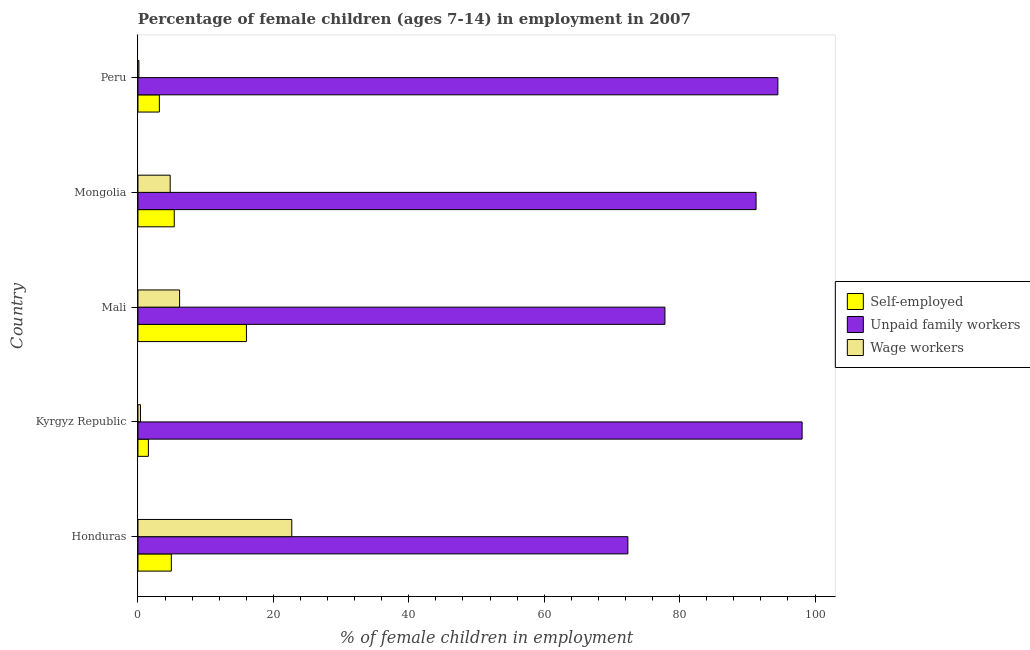How many different coloured bars are there?
Your answer should be compact. 3. How many groups of bars are there?
Your answer should be compact. 5. Are the number of bars on each tick of the Y-axis equal?
Your answer should be very brief. Yes. What is the label of the 3rd group of bars from the top?
Offer a terse response. Mali. In how many cases, is the number of bars for a given country not equal to the number of legend labels?
Make the answer very short. 0. What is the percentage of children employed as unpaid family workers in Peru?
Provide a short and direct response. 94.51. Across all countries, what is the maximum percentage of self employed children?
Your answer should be very brief. 16.02. Across all countries, what is the minimum percentage of self employed children?
Offer a very short reply. 1.54. In which country was the percentage of children employed as unpaid family workers maximum?
Provide a succinct answer. Kyrgyz Republic. In which country was the percentage of children employed as unpaid family workers minimum?
Give a very brief answer. Honduras. What is the total percentage of children employed as unpaid family workers in the graph?
Your answer should be very brief. 434.08. What is the difference between the percentage of self employed children in Kyrgyz Republic and that in Mongolia?
Your response must be concise. -3.82. What is the difference between the percentage of children employed as wage workers in Mongolia and the percentage of self employed children in Peru?
Your response must be concise. 1.6. What is the average percentage of children employed as wage workers per country?
Offer a terse response. 6.83. What is the difference between the percentage of children employed as wage workers and percentage of children employed as unpaid family workers in Mali?
Offer a very short reply. -71.68. What is the ratio of the percentage of self employed children in Kyrgyz Republic to that in Mali?
Your answer should be compact. 0.1. Is the percentage of children employed as unpaid family workers in Mongolia less than that in Peru?
Make the answer very short. Yes. What is the difference between the highest and the second highest percentage of children employed as unpaid family workers?
Your response must be concise. 3.58. What is the difference between the highest and the lowest percentage of self employed children?
Offer a terse response. 14.48. What does the 2nd bar from the top in Mali represents?
Ensure brevity in your answer.  Unpaid family workers. What does the 3rd bar from the bottom in Peru represents?
Provide a short and direct response. Wage workers. How many bars are there?
Your answer should be compact. 15. Are the values on the major ticks of X-axis written in scientific E-notation?
Offer a terse response. No. Does the graph contain grids?
Your answer should be compact. No. Where does the legend appear in the graph?
Give a very brief answer. Center right. What is the title of the graph?
Give a very brief answer. Percentage of female children (ages 7-14) in employment in 2007. What is the label or title of the X-axis?
Offer a terse response. % of female children in employment. What is the % of female children in employment of Self-employed in Honduras?
Offer a terse response. 4.93. What is the % of female children in employment of Unpaid family workers in Honduras?
Offer a very short reply. 72.36. What is the % of female children in employment of Wage workers in Honduras?
Provide a short and direct response. 22.72. What is the % of female children in employment in Self-employed in Kyrgyz Republic?
Your response must be concise. 1.54. What is the % of female children in employment in Unpaid family workers in Kyrgyz Republic?
Your response must be concise. 98.09. What is the % of female children in employment of Wage workers in Kyrgyz Republic?
Keep it short and to the point. 0.37. What is the % of female children in employment of Self-employed in Mali?
Ensure brevity in your answer.  16.02. What is the % of female children in employment of Unpaid family workers in Mali?
Ensure brevity in your answer.  77.83. What is the % of female children in employment in Wage workers in Mali?
Provide a succinct answer. 6.15. What is the % of female children in employment of Self-employed in Mongolia?
Ensure brevity in your answer.  5.36. What is the % of female children in employment in Unpaid family workers in Mongolia?
Give a very brief answer. 91.29. What is the % of female children in employment of Wage workers in Mongolia?
Keep it short and to the point. 4.76. What is the % of female children in employment in Self-employed in Peru?
Make the answer very short. 3.16. What is the % of female children in employment of Unpaid family workers in Peru?
Provide a short and direct response. 94.51. What is the % of female children in employment of Wage workers in Peru?
Ensure brevity in your answer.  0.14. Across all countries, what is the maximum % of female children in employment of Self-employed?
Offer a very short reply. 16.02. Across all countries, what is the maximum % of female children in employment in Unpaid family workers?
Your response must be concise. 98.09. Across all countries, what is the maximum % of female children in employment of Wage workers?
Your answer should be compact. 22.72. Across all countries, what is the minimum % of female children in employment in Self-employed?
Give a very brief answer. 1.54. Across all countries, what is the minimum % of female children in employment in Unpaid family workers?
Your answer should be compact. 72.36. Across all countries, what is the minimum % of female children in employment in Wage workers?
Provide a succinct answer. 0.14. What is the total % of female children in employment in Self-employed in the graph?
Your answer should be very brief. 31.01. What is the total % of female children in employment in Unpaid family workers in the graph?
Offer a very short reply. 434.08. What is the total % of female children in employment in Wage workers in the graph?
Ensure brevity in your answer.  34.14. What is the difference between the % of female children in employment in Self-employed in Honduras and that in Kyrgyz Republic?
Keep it short and to the point. 3.39. What is the difference between the % of female children in employment in Unpaid family workers in Honduras and that in Kyrgyz Republic?
Keep it short and to the point. -25.73. What is the difference between the % of female children in employment of Wage workers in Honduras and that in Kyrgyz Republic?
Your response must be concise. 22.35. What is the difference between the % of female children in employment of Self-employed in Honduras and that in Mali?
Offer a terse response. -11.09. What is the difference between the % of female children in employment of Unpaid family workers in Honduras and that in Mali?
Make the answer very short. -5.47. What is the difference between the % of female children in employment of Wage workers in Honduras and that in Mali?
Ensure brevity in your answer.  16.57. What is the difference between the % of female children in employment of Self-employed in Honduras and that in Mongolia?
Offer a very short reply. -0.43. What is the difference between the % of female children in employment in Unpaid family workers in Honduras and that in Mongolia?
Your response must be concise. -18.93. What is the difference between the % of female children in employment in Wage workers in Honduras and that in Mongolia?
Provide a short and direct response. 17.96. What is the difference between the % of female children in employment of Self-employed in Honduras and that in Peru?
Make the answer very short. 1.77. What is the difference between the % of female children in employment of Unpaid family workers in Honduras and that in Peru?
Provide a succinct answer. -22.15. What is the difference between the % of female children in employment in Wage workers in Honduras and that in Peru?
Give a very brief answer. 22.58. What is the difference between the % of female children in employment in Self-employed in Kyrgyz Republic and that in Mali?
Keep it short and to the point. -14.48. What is the difference between the % of female children in employment in Unpaid family workers in Kyrgyz Republic and that in Mali?
Provide a succinct answer. 20.26. What is the difference between the % of female children in employment in Wage workers in Kyrgyz Republic and that in Mali?
Your answer should be compact. -5.78. What is the difference between the % of female children in employment in Self-employed in Kyrgyz Republic and that in Mongolia?
Offer a terse response. -3.82. What is the difference between the % of female children in employment of Unpaid family workers in Kyrgyz Republic and that in Mongolia?
Offer a terse response. 6.8. What is the difference between the % of female children in employment of Wage workers in Kyrgyz Republic and that in Mongolia?
Your response must be concise. -4.39. What is the difference between the % of female children in employment of Self-employed in Kyrgyz Republic and that in Peru?
Make the answer very short. -1.62. What is the difference between the % of female children in employment in Unpaid family workers in Kyrgyz Republic and that in Peru?
Give a very brief answer. 3.58. What is the difference between the % of female children in employment in Wage workers in Kyrgyz Republic and that in Peru?
Provide a short and direct response. 0.23. What is the difference between the % of female children in employment of Self-employed in Mali and that in Mongolia?
Offer a terse response. 10.66. What is the difference between the % of female children in employment in Unpaid family workers in Mali and that in Mongolia?
Make the answer very short. -13.46. What is the difference between the % of female children in employment in Wage workers in Mali and that in Mongolia?
Provide a succinct answer. 1.39. What is the difference between the % of female children in employment of Self-employed in Mali and that in Peru?
Your response must be concise. 12.86. What is the difference between the % of female children in employment of Unpaid family workers in Mali and that in Peru?
Your answer should be very brief. -16.68. What is the difference between the % of female children in employment in Wage workers in Mali and that in Peru?
Your answer should be very brief. 6.01. What is the difference between the % of female children in employment of Self-employed in Mongolia and that in Peru?
Offer a very short reply. 2.2. What is the difference between the % of female children in employment in Unpaid family workers in Mongolia and that in Peru?
Your answer should be compact. -3.22. What is the difference between the % of female children in employment in Wage workers in Mongolia and that in Peru?
Your answer should be very brief. 4.62. What is the difference between the % of female children in employment of Self-employed in Honduras and the % of female children in employment of Unpaid family workers in Kyrgyz Republic?
Provide a succinct answer. -93.16. What is the difference between the % of female children in employment of Self-employed in Honduras and the % of female children in employment of Wage workers in Kyrgyz Republic?
Your answer should be compact. 4.56. What is the difference between the % of female children in employment of Unpaid family workers in Honduras and the % of female children in employment of Wage workers in Kyrgyz Republic?
Ensure brevity in your answer.  71.99. What is the difference between the % of female children in employment of Self-employed in Honduras and the % of female children in employment of Unpaid family workers in Mali?
Provide a short and direct response. -72.9. What is the difference between the % of female children in employment of Self-employed in Honduras and the % of female children in employment of Wage workers in Mali?
Provide a short and direct response. -1.22. What is the difference between the % of female children in employment of Unpaid family workers in Honduras and the % of female children in employment of Wage workers in Mali?
Your answer should be compact. 66.21. What is the difference between the % of female children in employment in Self-employed in Honduras and the % of female children in employment in Unpaid family workers in Mongolia?
Ensure brevity in your answer.  -86.36. What is the difference between the % of female children in employment of Self-employed in Honduras and the % of female children in employment of Wage workers in Mongolia?
Provide a short and direct response. 0.17. What is the difference between the % of female children in employment of Unpaid family workers in Honduras and the % of female children in employment of Wage workers in Mongolia?
Your answer should be very brief. 67.6. What is the difference between the % of female children in employment in Self-employed in Honduras and the % of female children in employment in Unpaid family workers in Peru?
Ensure brevity in your answer.  -89.58. What is the difference between the % of female children in employment in Self-employed in Honduras and the % of female children in employment in Wage workers in Peru?
Provide a short and direct response. 4.79. What is the difference between the % of female children in employment in Unpaid family workers in Honduras and the % of female children in employment in Wage workers in Peru?
Keep it short and to the point. 72.22. What is the difference between the % of female children in employment of Self-employed in Kyrgyz Republic and the % of female children in employment of Unpaid family workers in Mali?
Ensure brevity in your answer.  -76.29. What is the difference between the % of female children in employment in Self-employed in Kyrgyz Republic and the % of female children in employment in Wage workers in Mali?
Your response must be concise. -4.61. What is the difference between the % of female children in employment in Unpaid family workers in Kyrgyz Republic and the % of female children in employment in Wage workers in Mali?
Give a very brief answer. 91.94. What is the difference between the % of female children in employment of Self-employed in Kyrgyz Republic and the % of female children in employment of Unpaid family workers in Mongolia?
Your answer should be compact. -89.75. What is the difference between the % of female children in employment in Self-employed in Kyrgyz Republic and the % of female children in employment in Wage workers in Mongolia?
Give a very brief answer. -3.22. What is the difference between the % of female children in employment of Unpaid family workers in Kyrgyz Republic and the % of female children in employment of Wage workers in Mongolia?
Offer a very short reply. 93.33. What is the difference between the % of female children in employment of Self-employed in Kyrgyz Republic and the % of female children in employment of Unpaid family workers in Peru?
Give a very brief answer. -92.97. What is the difference between the % of female children in employment in Self-employed in Kyrgyz Republic and the % of female children in employment in Wage workers in Peru?
Your answer should be compact. 1.4. What is the difference between the % of female children in employment of Unpaid family workers in Kyrgyz Republic and the % of female children in employment of Wage workers in Peru?
Your answer should be compact. 97.95. What is the difference between the % of female children in employment of Self-employed in Mali and the % of female children in employment of Unpaid family workers in Mongolia?
Your answer should be very brief. -75.27. What is the difference between the % of female children in employment in Self-employed in Mali and the % of female children in employment in Wage workers in Mongolia?
Offer a very short reply. 11.26. What is the difference between the % of female children in employment in Unpaid family workers in Mali and the % of female children in employment in Wage workers in Mongolia?
Your answer should be very brief. 73.07. What is the difference between the % of female children in employment of Self-employed in Mali and the % of female children in employment of Unpaid family workers in Peru?
Make the answer very short. -78.49. What is the difference between the % of female children in employment of Self-employed in Mali and the % of female children in employment of Wage workers in Peru?
Your answer should be compact. 15.88. What is the difference between the % of female children in employment in Unpaid family workers in Mali and the % of female children in employment in Wage workers in Peru?
Ensure brevity in your answer.  77.69. What is the difference between the % of female children in employment in Self-employed in Mongolia and the % of female children in employment in Unpaid family workers in Peru?
Your answer should be compact. -89.15. What is the difference between the % of female children in employment of Self-employed in Mongolia and the % of female children in employment of Wage workers in Peru?
Your answer should be very brief. 5.22. What is the difference between the % of female children in employment in Unpaid family workers in Mongolia and the % of female children in employment in Wage workers in Peru?
Make the answer very short. 91.15. What is the average % of female children in employment in Self-employed per country?
Your answer should be very brief. 6.2. What is the average % of female children in employment of Unpaid family workers per country?
Offer a very short reply. 86.82. What is the average % of female children in employment in Wage workers per country?
Your response must be concise. 6.83. What is the difference between the % of female children in employment in Self-employed and % of female children in employment in Unpaid family workers in Honduras?
Offer a very short reply. -67.43. What is the difference between the % of female children in employment in Self-employed and % of female children in employment in Wage workers in Honduras?
Provide a succinct answer. -17.79. What is the difference between the % of female children in employment of Unpaid family workers and % of female children in employment of Wage workers in Honduras?
Provide a short and direct response. 49.64. What is the difference between the % of female children in employment in Self-employed and % of female children in employment in Unpaid family workers in Kyrgyz Republic?
Keep it short and to the point. -96.55. What is the difference between the % of female children in employment in Self-employed and % of female children in employment in Wage workers in Kyrgyz Republic?
Keep it short and to the point. 1.17. What is the difference between the % of female children in employment in Unpaid family workers and % of female children in employment in Wage workers in Kyrgyz Republic?
Offer a terse response. 97.72. What is the difference between the % of female children in employment in Self-employed and % of female children in employment in Unpaid family workers in Mali?
Keep it short and to the point. -61.81. What is the difference between the % of female children in employment of Self-employed and % of female children in employment of Wage workers in Mali?
Make the answer very short. 9.87. What is the difference between the % of female children in employment of Unpaid family workers and % of female children in employment of Wage workers in Mali?
Your answer should be very brief. 71.68. What is the difference between the % of female children in employment of Self-employed and % of female children in employment of Unpaid family workers in Mongolia?
Give a very brief answer. -85.93. What is the difference between the % of female children in employment in Self-employed and % of female children in employment in Wage workers in Mongolia?
Your answer should be compact. 0.6. What is the difference between the % of female children in employment of Unpaid family workers and % of female children in employment of Wage workers in Mongolia?
Your answer should be very brief. 86.53. What is the difference between the % of female children in employment in Self-employed and % of female children in employment in Unpaid family workers in Peru?
Provide a short and direct response. -91.35. What is the difference between the % of female children in employment of Self-employed and % of female children in employment of Wage workers in Peru?
Your response must be concise. 3.02. What is the difference between the % of female children in employment in Unpaid family workers and % of female children in employment in Wage workers in Peru?
Give a very brief answer. 94.37. What is the ratio of the % of female children in employment of Self-employed in Honduras to that in Kyrgyz Republic?
Your answer should be very brief. 3.2. What is the ratio of the % of female children in employment of Unpaid family workers in Honduras to that in Kyrgyz Republic?
Provide a succinct answer. 0.74. What is the ratio of the % of female children in employment of Wage workers in Honduras to that in Kyrgyz Republic?
Your response must be concise. 61.41. What is the ratio of the % of female children in employment of Self-employed in Honduras to that in Mali?
Your answer should be very brief. 0.31. What is the ratio of the % of female children in employment of Unpaid family workers in Honduras to that in Mali?
Your response must be concise. 0.93. What is the ratio of the % of female children in employment of Wage workers in Honduras to that in Mali?
Your answer should be compact. 3.69. What is the ratio of the % of female children in employment in Self-employed in Honduras to that in Mongolia?
Keep it short and to the point. 0.92. What is the ratio of the % of female children in employment of Unpaid family workers in Honduras to that in Mongolia?
Your answer should be compact. 0.79. What is the ratio of the % of female children in employment in Wage workers in Honduras to that in Mongolia?
Your answer should be compact. 4.77. What is the ratio of the % of female children in employment in Self-employed in Honduras to that in Peru?
Offer a very short reply. 1.56. What is the ratio of the % of female children in employment of Unpaid family workers in Honduras to that in Peru?
Your answer should be compact. 0.77. What is the ratio of the % of female children in employment of Wage workers in Honduras to that in Peru?
Give a very brief answer. 162.29. What is the ratio of the % of female children in employment of Self-employed in Kyrgyz Republic to that in Mali?
Your answer should be very brief. 0.1. What is the ratio of the % of female children in employment in Unpaid family workers in Kyrgyz Republic to that in Mali?
Ensure brevity in your answer.  1.26. What is the ratio of the % of female children in employment of Wage workers in Kyrgyz Republic to that in Mali?
Your answer should be compact. 0.06. What is the ratio of the % of female children in employment in Self-employed in Kyrgyz Republic to that in Mongolia?
Your response must be concise. 0.29. What is the ratio of the % of female children in employment in Unpaid family workers in Kyrgyz Republic to that in Mongolia?
Ensure brevity in your answer.  1.07. What is the ratio of the % of female children in employment in Wage workers in Kyrgyz Republic to that in Mongolia?
Offer a terse response. 0.08. What is the ratio of the % of female children in employment in Self-employed in Kyrgyz Republic to that in Peru?
Make the answer very short. 0.49. What is the ratio of the % of female children in employment of Unpaid family workers in Kyrgyz Republic to that in Peru?
Provide a short and direct response. 1.04. What is the ratio of the % of female children in employment of Wage workers in Kyrgyz Republic to that in Peru?
Your answer should be compact. 2.64. What is the ratio of the % of female children in employment of Self-employed in Mali to that in Mongolia?
Your response must be concise. 2.99. What is the ratio of the % of female children in employment in Unpaid family workers in Mali to that in Mongolia?
Your answer should be compact. 0.85. What is the ratio of the % of female children in employment of Wage workers in Mali to that in Mongolia?
Make the answer very short. 1.29. What is the ratio of the % of female children in employment of Self-employed in Mali to that in Peru?
Offer a very short reply. 5.07. What is the ratio of the % of female children in employment of Unpaid family workers in Mali to that in Peru?
Provide a succinct answer. 0.82. What is the ratio of the % of female children in employment in Wage workers in Mali to that in Peru?
Your answer should be compact. 43.93. What is the ratio of the % of female children in employment in Self-employed in Mongolia to that in Peru?
Give a very brief answer. 1.7. What is the ratio of the % of female children in employment of Unpaid family workers in Mongolia to that in Peru?
Offer a very short reply. 0.97. What is the ratio of the % of female children in employment of Wage workers in Mongolia to that in Peru?
Your answer should be compact. 34. What is the difference between the highest and the second highest % of female children in employment in Self-employed?
Offer a terse response. 10.66. What is the difference between the highest and the second highest % of female children in employment in Unpaid family workers?
Your answer should be very brief. 3.58. What is the difference between the highest and the second highest % of female children in employment in Wage workers?
Give a very brief answer. 16.57. What is the difference between the highest and the lowest % of female children in employment of Self-employed?
Keep it short and to the point. 14.48. What is the difference between the highest and the lowest % of female children in employment of Unpaid family workers?
Your response must be concise. 25.73. What is the difference between the highest and the lowest % of female children in employment in Wage workers?
Offer a terse response. 22.58. 